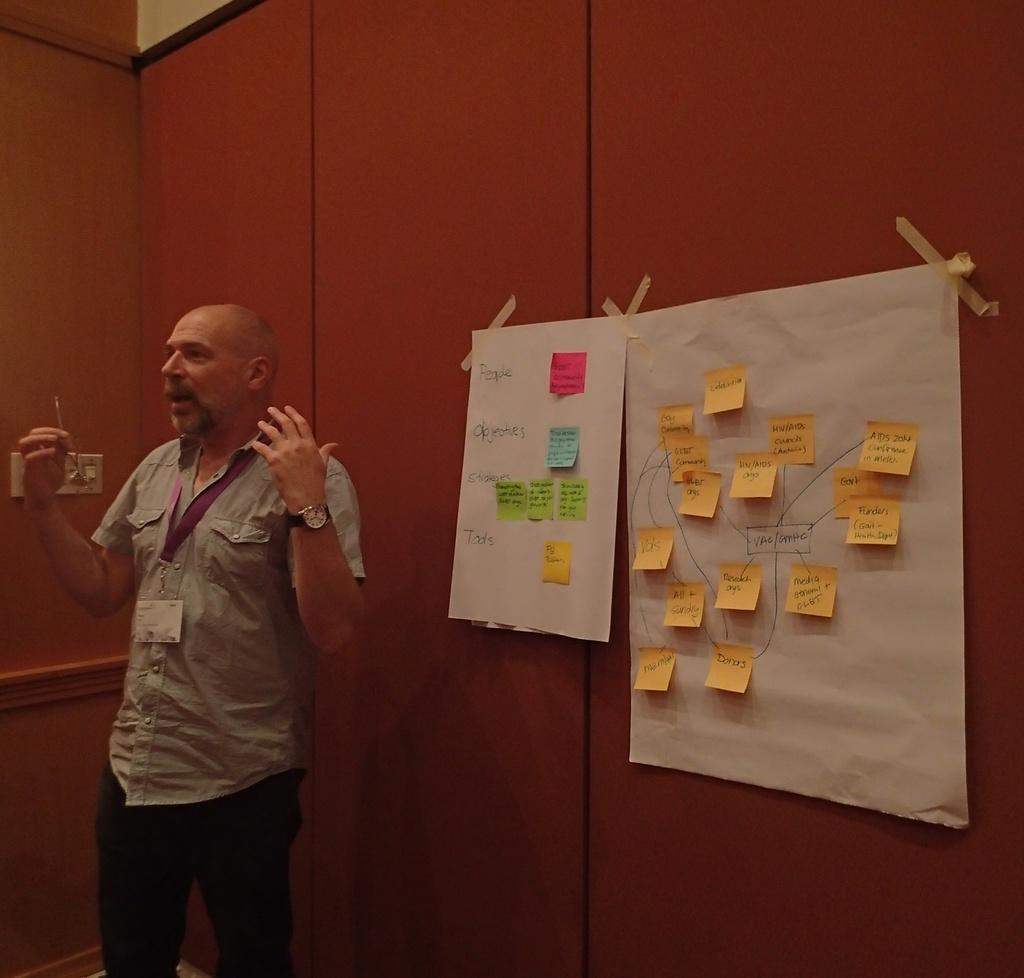Who is present in the image? There is a man in the image. What is the man wearing that identifies him? The man is wearing an ID card. What accessory is the man wearing on his wrist? The man is wearing a watch. What can be seen in the background of the image? There are walls, posters, and a socket in the background of the image. What type of bone is the man holding in the image? There is no bone present in the image; the man is wearing an ID card and a watch. 